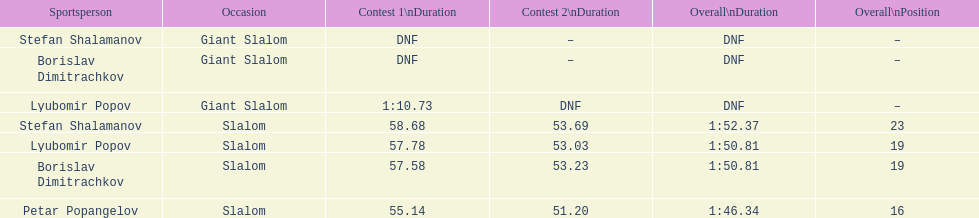What is the difference in time for petar popangelov in race 1and 2 3.94. 